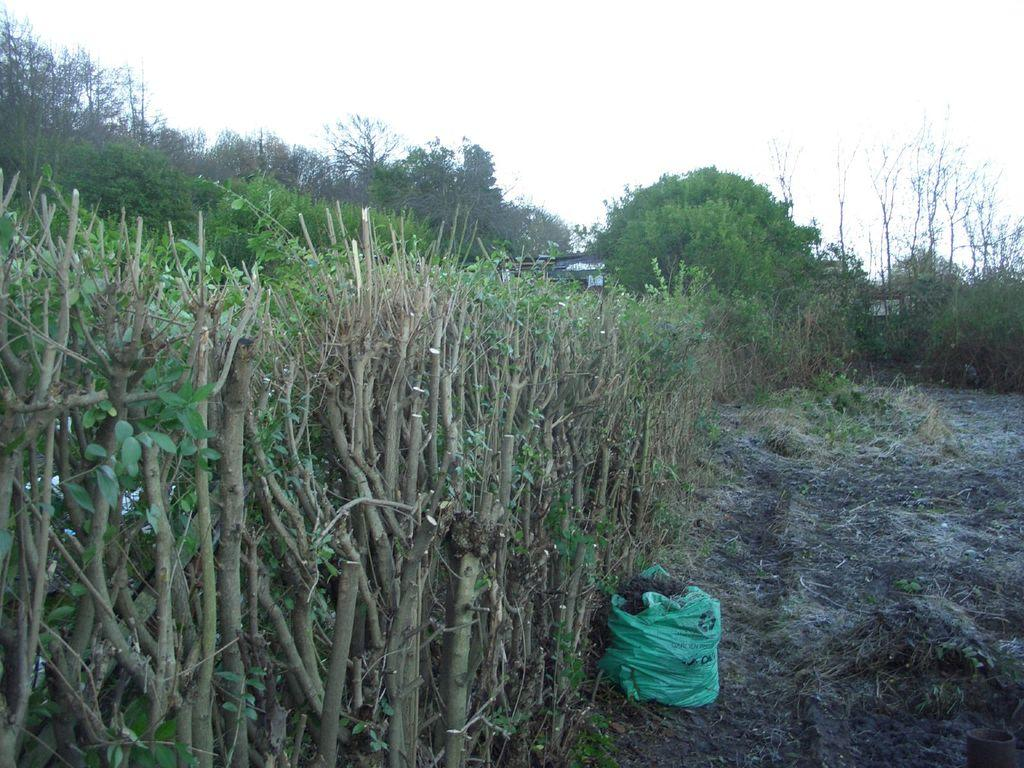What object can be seen in the image? There is a bag in the image. What type of terrain is visible in the image? There is grass on the ground in the image. What can be found on the left side of the image? There are plants on the left side of the image. What is visible in the background of the image? There are trees, objects, and the sky in the background of the image. What scent can be detected coming from the bag in the image? There is no information about the scent of the bag in the image, so it cannot be determined. 